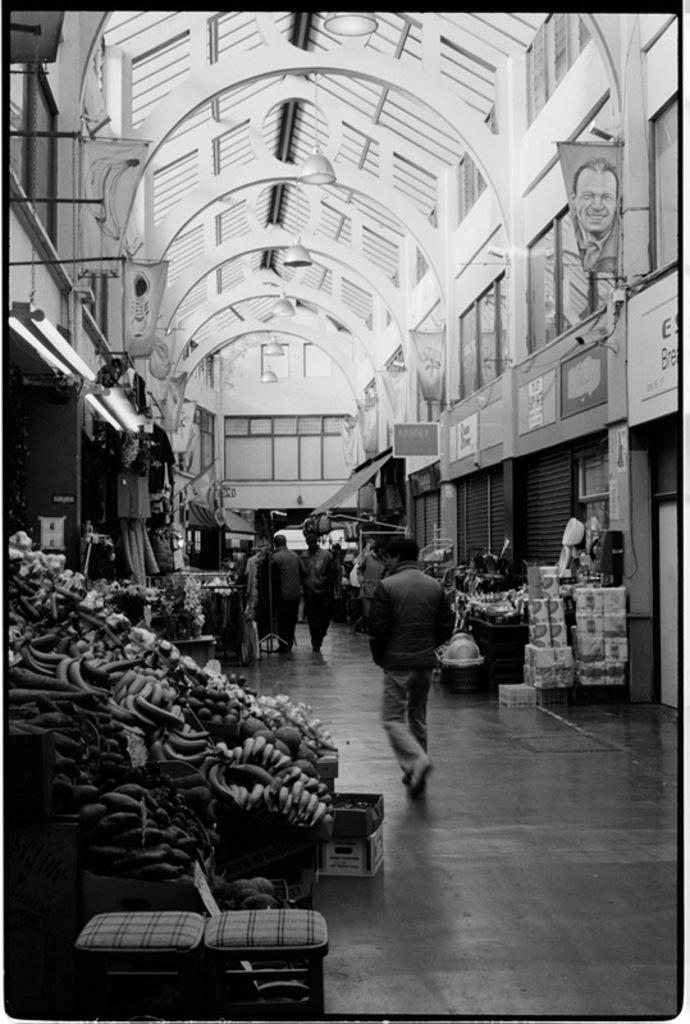How would you summarize this image in a sentence or two? This is a black and white picture. Here we can see people, boxes, lights, roof, banners, boards, shutters, fruits, stools, floor, and other objects. 